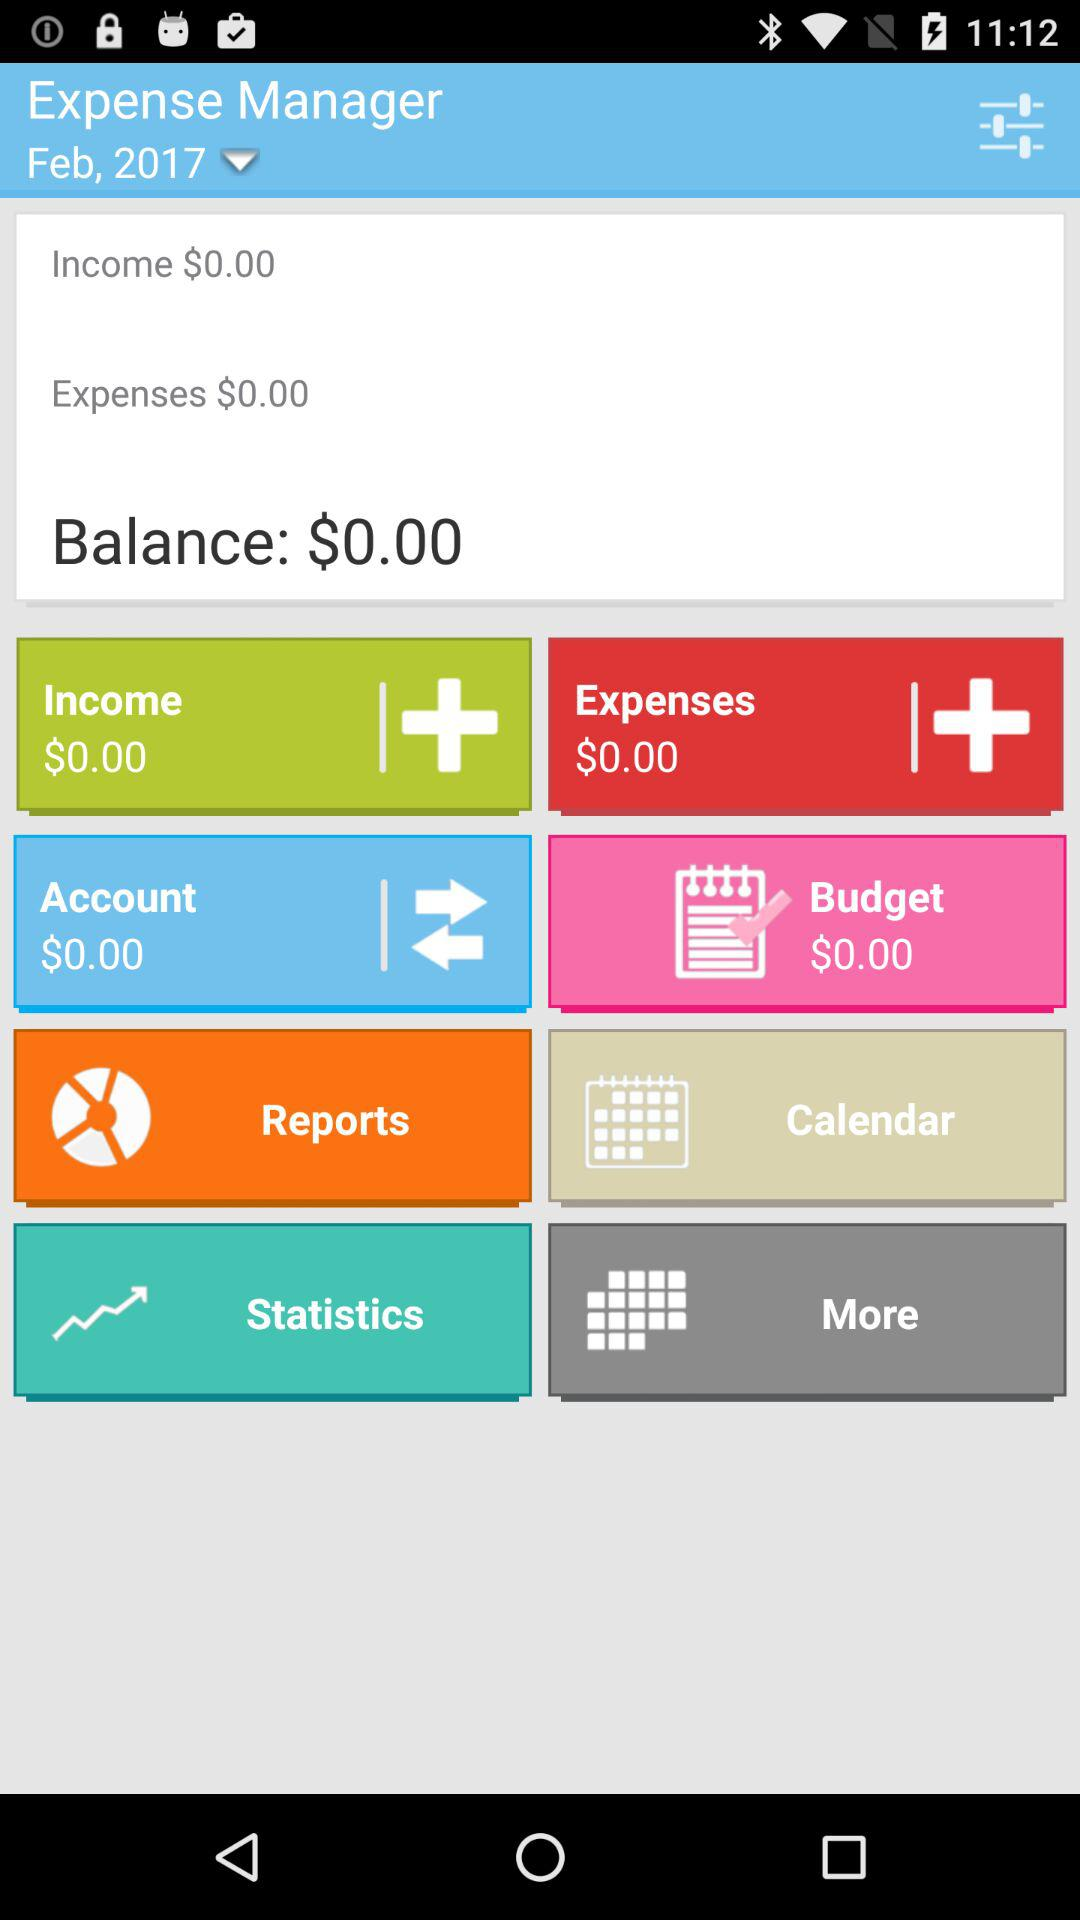What are the month and year given there? The given month and year are February and 2017. 